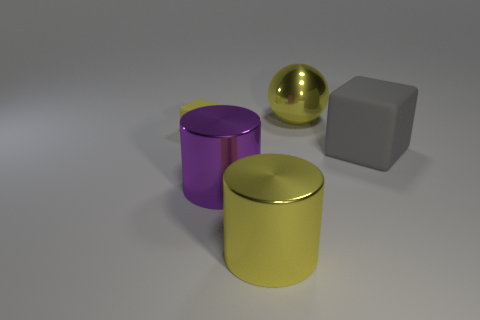Add 5 large purple metallic things. How many objects exist? 10 Subtract all blocks. How many objects are left? 3 Add 1 yellow metallic balls. How many yellow metallic balls are left? 2 Add 5 brown matte cubes. How many brown matte cubes exist? 5 Subtract 0 cyan cylinders. How many objects are left? 5 Subtract 2 cubes. How many cubes are left? 0 Subtract all red balls. Subtract all cyan cylinders. How many balls are left? 1 Subtract all green balls. How many purple cubes are left? 0 Subtract all large yellow metal cylinders. Subtract all large gray blocks. How many objects are left? 3 